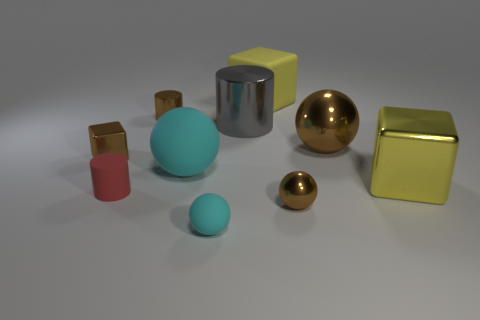What is the tiny red cylinder made of?
Provide a short and direct response. Rubber. Is the number of tiny red matte cylinders in front of the red object greater than the number of large blue shiny cylinders?
Keep it short and to the point. No. What number of large yellow things are behind the large sphere that is in front of the metal block that is left of the yellow rubber block?
Your response must be concise. 1. There is a sphere that is in front of the tiny cube and to the right of the yellow rubber thing; what is its material?
Offer a terse response. Metal. What is the color of the tiny shiny cube?
Ensure brevity in your answer.  Brown. Are there more tiny rubber balls right of the tiny matte cylinder than big shiny cubes behind the large cyan rubber sphere?
Your answer should be very brief. Yes. There is a tiny object to the right of the small cyan sphere; what is its color?
Provide a short and direct response. Brown. There is a cyan matte object that is behind the small cyan sphere; is it the same size as the shiny block that is on the left side of the small cyan ball?
Your response must be concise. No. How many things are either large brown things or red cylinders?
Give a very brief answer. 2. What is the cyan thing to the left of the cyan rubber ball in front of the big yellow shiny object made of?
Offer a very short reply. Rubber. 